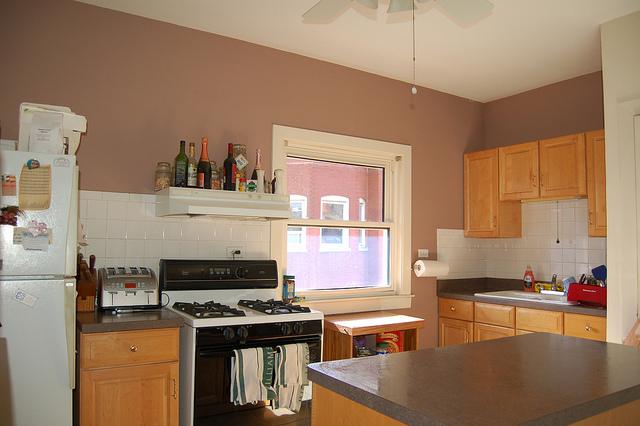What is hanging on the stove handle?
Answer briefly. Towels. Does the window have curtains?
Quick response, please. No. How many people can be seen in the picture?
Keep it brief. 0. Are there places to sit down?
Quick response, please. No. What is on the cooker?
Short answer required. Nothing. 